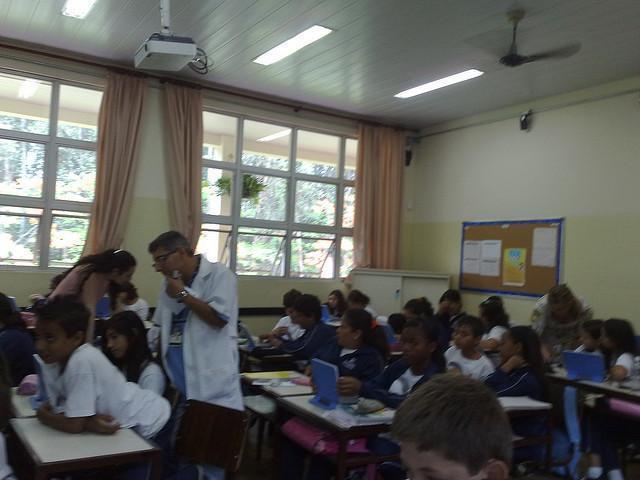What is the person in the white coat doing?
Indicate the correct response and explain using: 'Answer: answer
Rationale: rationale.'
Options: Shaving, taking vacation, having lunch, teaching. Answer: teaching.
Rationale: He is a instructor in a classroom full of kids. 